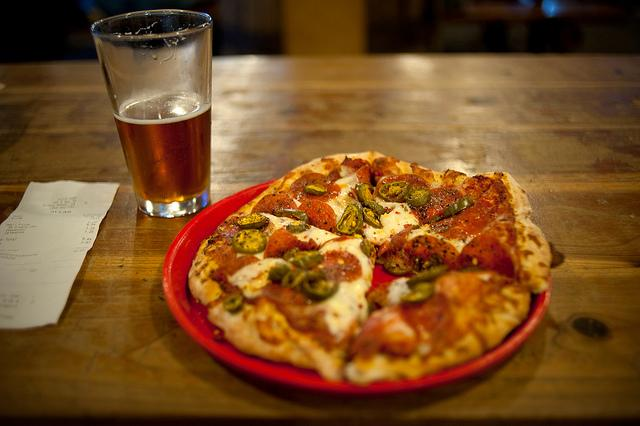What are the green items on top of the pizza? Please explain your reasoning. jalapenos. Jalapenos are cut into rings. 